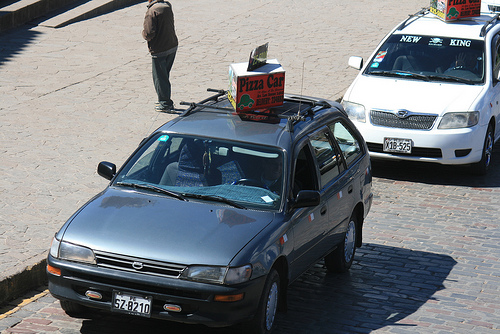<image>
Is the brown pants in the white jacket? No. The brown pants is not contained within the white jacket. These objects have a different spatial relationship. Is the blue car in front of the white car? Yes. The blue car is positioned in front of the white car, appearing closer to the camera viewpoint. 